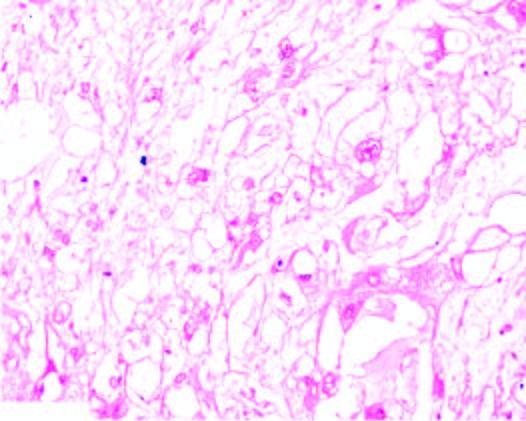re the tumour cells quite variable in size having characteristic bubbly cytoplasm and anisonucleocytosis?
Answer the question using a single word or phrase. Yes 